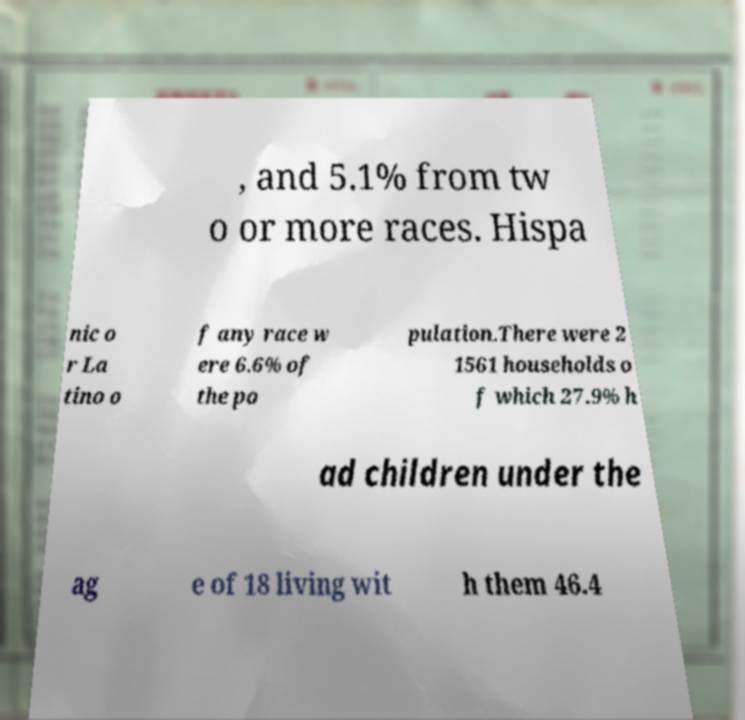Can you read and provide the text displayed in the image?This photo seems to have some interesting text. Can you extract and type it out for me? , and 5.1% from tw o or more races. Hispa nic o r La tino o f any race w ere 6.6% of the po pulation.There were 2 1561 households o f which 27.9% h ad children under the ag e of 18 living wit h them 46.4 